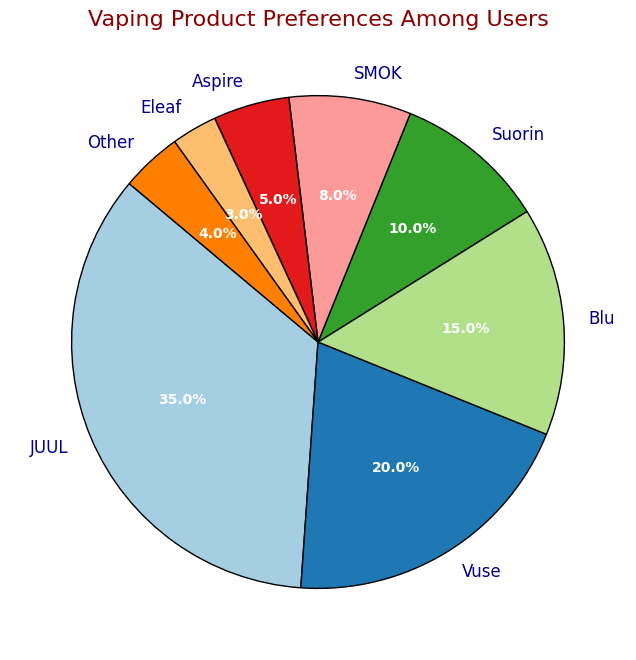What's the most preferred vaping brand among users? By looking at the figure, identify the brand with the largest percentage. JUUL has the largest slice of the pie chart, representing 35% of user preferences.
Answer: JUUL Which two brands are least preferred by users? Identify the two smallest slices in the pie chart. Eleaf and Aspire have the smallest percentages with 3% and 5%, respectively. Hence, Eleaf and Other are the least preferred.
Answer: Eleaf and Other What's the combined percentage of users who prefer Suorin and SMOK? Locate the percentages for Suorin and SMOK in the pie chart. Add these two values: 10% (Suorin) + 8% (SMOK).
Answer: 18% How does the preference for Vuse compare to Blu? Compare the sizes of the Vuse and Blu slices in the pie chart. Vuse is larger at 20%, whereas Blu is smaller at 15%.
Answer: Vuse is preferred more Is there a significant difference in preference between Aspire and Other? Compare the sizes of the Aspire and Other slices in the pie chart. Aspire has 5% and Other has 4%, which indicates a tiny preference difference.
Answer: No, the difference is minimal What percentage of users prefer brands other than the top three? Identify the top three brands (JUUL, Vuse, Blu) from the pie chart and sum their percentages: 35% + 20% + 15%. Subtract this sum from 100% to find the combined percentage of remaining brands: 100% - 70% = 30%.
Answer: 30% Is the percentage of users preferring Blu more than the combined percentage of Eleaf and Other? Identify and compare the percentages for Blu (15%) with the sum of Eleaf (3%) and Other (4%). Blu is 15% while Eleaf + Other = 3% + 4% = 7%.
Answer: Yes What’s the difference in user preference between the most and least preferred brands? Identify the most and least preferred brands (JUUL 35% and Eleaf 3%). Calculate the difference: 35% - 3% = 32%.
Answer: 32% What’s the average percentage preference of the bottom three brands? Identify the bottom three brands (Eleaf, Other, Aspire). Sum their percentages: 3% + 4% + 5% = 12%. Calculate the average: 12% / 3 = 4%.
Answer: 4% 